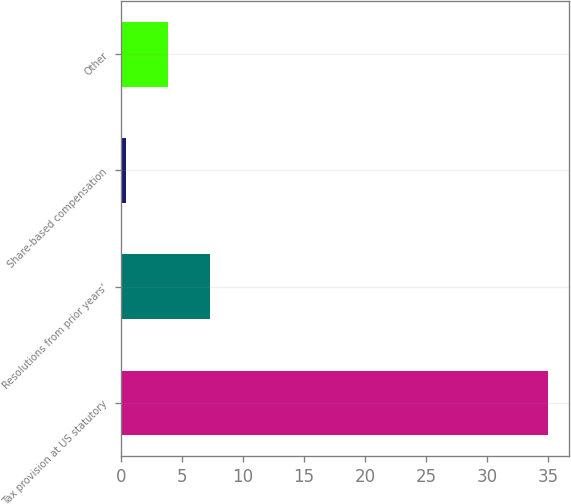Convert chart to OTSL. <chart><loc_0><loc_0><loc_500><loc_500><bar_chart><fcel>Tax provision at US statutory<fcel>Resolutions from prior years'<fcel>Share-based compensation<fcel>Other<nl><fcel>35<fcel>7.32<fcel>0.4<fcel>3.86<nl></chart> 